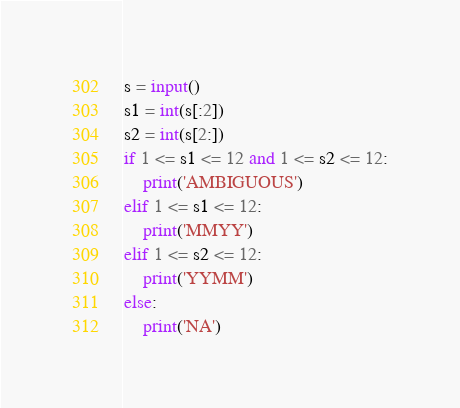Convert code to text. <code><loc_0><loc_0><loc_500><loc_500><_Python_>s = input()
s1 = int(s[:2])
s2 = int(s[2:])
if 1 <= s1 <= 12 and 1 <= s2 <= 12:
    print('AMBIGUOUS')
elif 1 <= s1 <= 12:
    print('MMYY')
elif 1 <= s2 <= 12:
    print('YYMM')
else:
    print('NA')</code> 